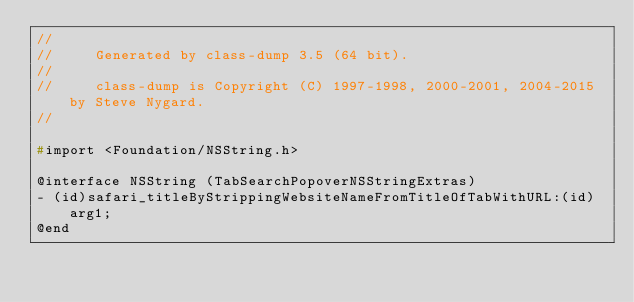<code> <loc_0><loc_0><loc_500><loc_500><_C_>//
//     Generated by class-dump 3.5 (64 bit).
//
//     class-dump is Copyright (C) 1997-1998, 2000-2001, 2004-2015 by Steve Nygard.
//

#import <Foundation/NSString.h>

@interface NSString (TabSearchPopoverNSStringExtras)
- (id)safari_titleByStrippingWebsiteNameFromTitleOfTabWithURL:(id)arg1;
@end

</code> 